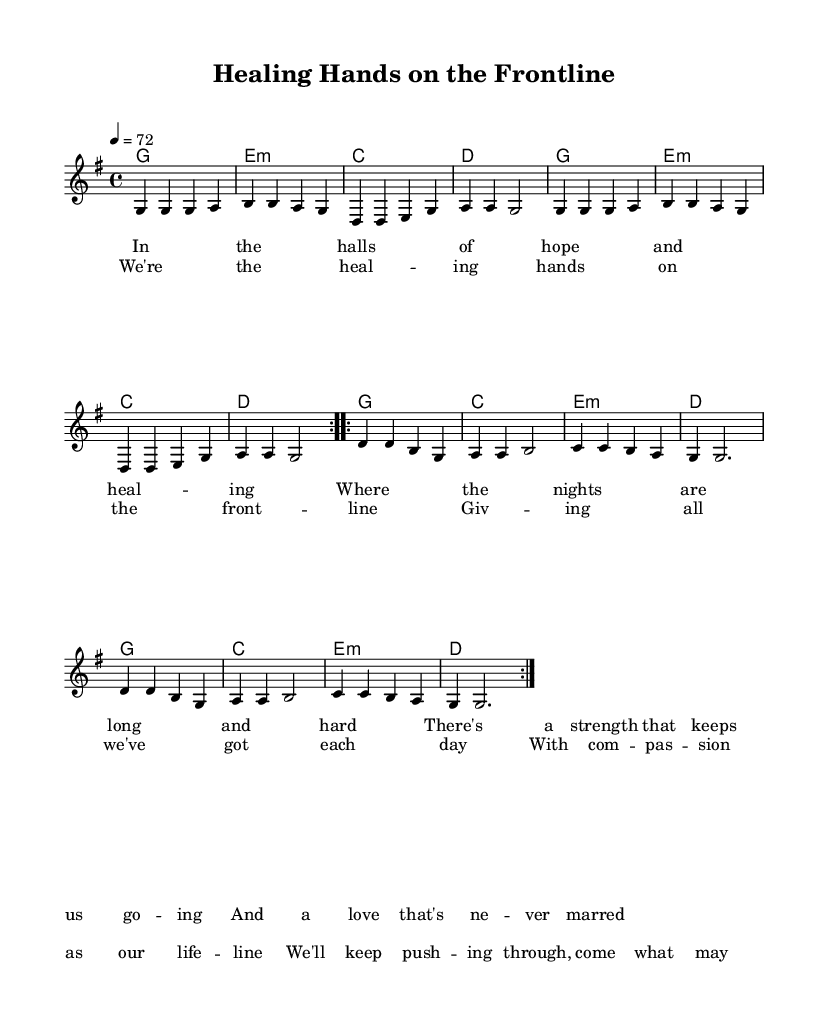What is the key signature of this music? The key signature is G major, which has one sharp (F#). We can determine this from the global section of the code where the key is set.
Answer: G major What is the time signature of this music? The time signature is 4/4, which indicates four beats per measure. This is also specified in the global section of the code.
Answer: 4/4 What is the tempo marking in this piece? The tempo marking is 4 = 72, meaning that there are 72 quarter notes per minute. This can be found in the global section of the code.
Answer: 72 How many times is the chorus repeated? The chorus is repeated twice as indicated by the \repeat volta 2 command in the melody structure.
Answer: 2 In which section do we find the lyrics describing dedication despite challenges? The lyrics that describe dedication despite challenges are found in the chorus section, where it talks about giving all and pushing through. This thematic element aligns with the content of the lyrics.
Answer: Chorus What chord is played during the first measure? The first measure features the G major chord, as indicated in the harmonies section that starts with g1.
Answer: G How many lines of lyrics are in the verse? There are four lines of lyrics in the verse, as indicated by the \verseOne command that contains four distinct lyric lines.
Answer: 4 